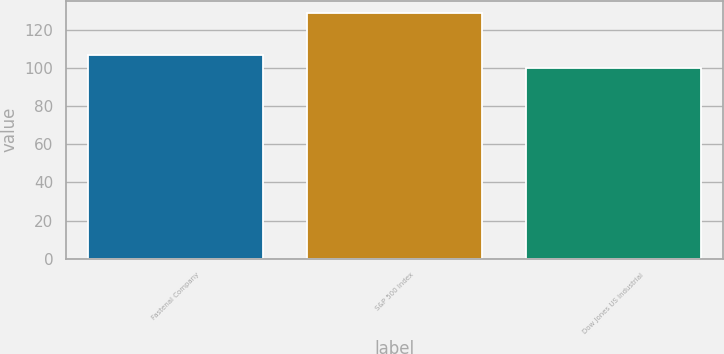Convert chart to OTSL. <chart><loc_0><loc_0><loc_500><loc_500><bar_chart><fcel>Fastenal Company<fcel>S&P 500 Index<fcel>Dow Jones US Industrial<nl><fcel>106.97<fcel>129.05<fcel>100.08<nl></chart> 